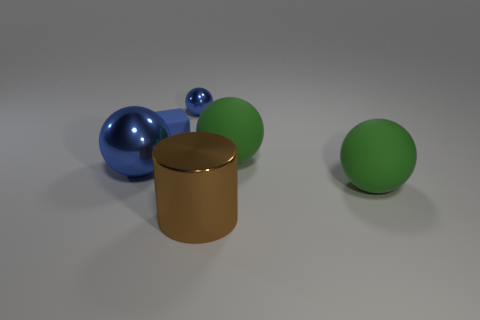Are there any metal things that are in front of the big shiny thing left of the metallic sphere that is right of the blue rubber object?
Your answer should be compact. Yes. How many other objects are the same material as the big cylinder?
Give a very brief answer. 2. How many cyan cubes are there?
Provide a short and direct response. 0. What number of objects are blue metallic things or blue things on the right side of the cube?
Provide a short and direct response. 2. Is there any other thing that has the same shape as the tiny matte thing?
Provide a short and direct response. No. There is a thing left of the blue cube; is it the same size as the blue rubber block?
Offer a terse response. No. How many rubber things are either tiny blue balls or large green things?
Your response must be concise. 2. There is a blue shiny object in front of the tiny cube; how big is it?
Offer a terse response. Large. Is the shape of the blue rubber thing the same as the tiny metallic thing?
Keep it short and to the point. No. What number of tiny things are green things or shiny things?
Make the answer very short. 1. 